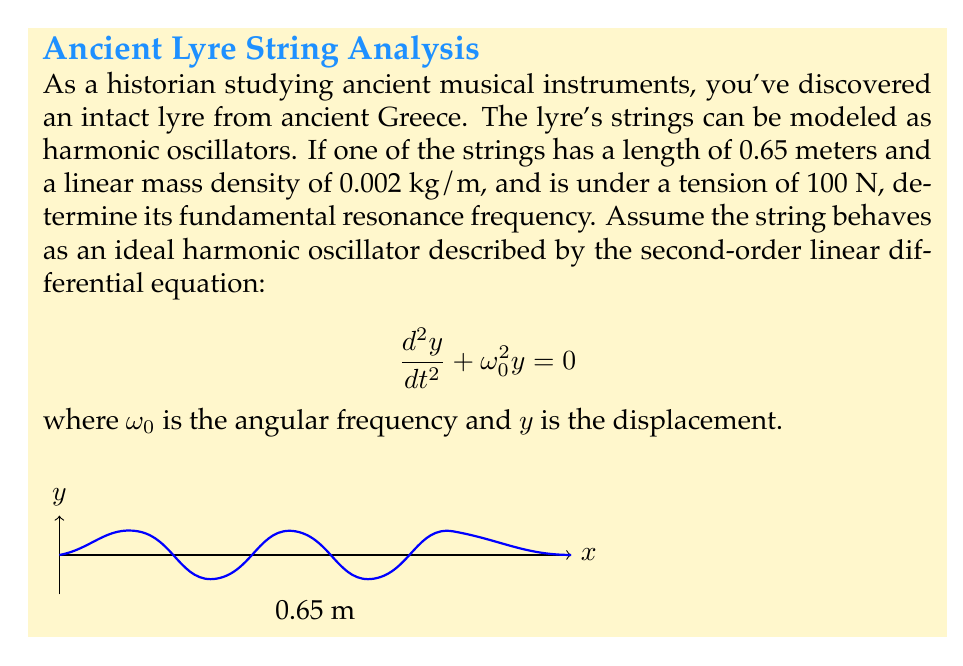Solve this math problem. To solve this problem, we'll follow these steps:

1) For a vibrating string, the angular frequency $\omega_0$ is given by:

   $$\omega_0 = \sqrt{\frac{T}{\mu}}$$

   where $T$ is the tension and $\mu$ is the linear mass density.

2) We're given:
   - Length $L = 0.65$ m
   - Linear mass density $\mu = 0.002$ kg/m
   - Tension $T = 100$ N

3) Let's calculate $\omega_0$:

   $$\omega_0 = \sqrt{\frac{100}{0.002}} = \sqrt{50000} = 223.61 \text{ rad/s}$$

4) The angular frequency $\omega_0$ is related to the frequency $f$ by:

   $$\omega_0 = 2\pi f$$

5) Solving for $f$:

   $$f = \frac{\omega_0}{2\pi} = \frac{223.61}{2\pi} = 35.59 \text{ Hz}$$

6) This is the fundamental frequency of the string. In musical terms, this would be the lowest note the string can produce.
Answer: 35.59 Hz 